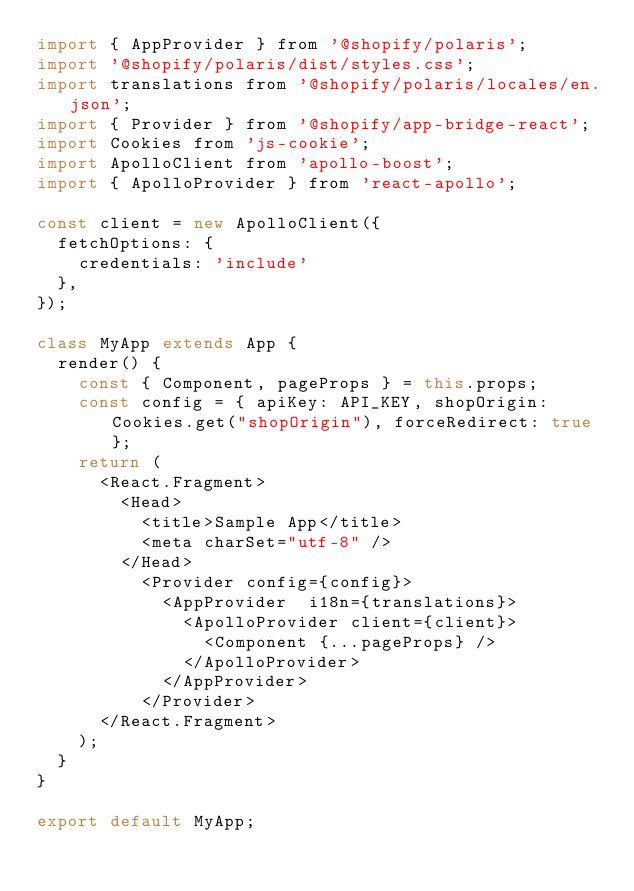<code> <loc_0><loc_0><loc_500><loc_500><_JavaScript_>import { AppProvider } from '@shopify/polaris';
import '@shopify/polaris/dist/styles.css';
import translations from '@shopify/polaris/locales/en.json';
import { Provider } from '@shopify/app-bridge-react';
import Cookies from 'js-cookie';
import ApolloClient from 'apollo-boost';
import { ApolloProvider } from 'react-apollo';

const client = new ApolloClient({
  fetchOptions: {
    credentials: 'include'
  },
});

class MyApp extends App {
  render() {
    const { Component, pageProps } = this.props;
    const config = { apiKey: API_KEY, shopOrigin: Cookies.get("shopOrigin"), forceRedirect: true };
    return (
      <React.Fragment>
        <Head>
          <title>Sample App</title>
          <meta charSet="utf-8" />
        </Head>
          <Provider config={config}>
            <AppProvider  i18n={translations}>
              <ApolloProvider client={client}>
                <Component {...pageProps} />
              </ApolloProvider>
            </AppProvider>
          </Provider>
      </React.Fragment>
    );
  }
}

export default MyApp;</code> 